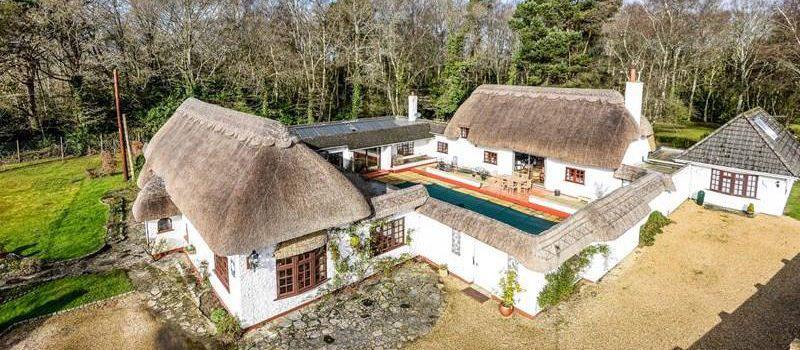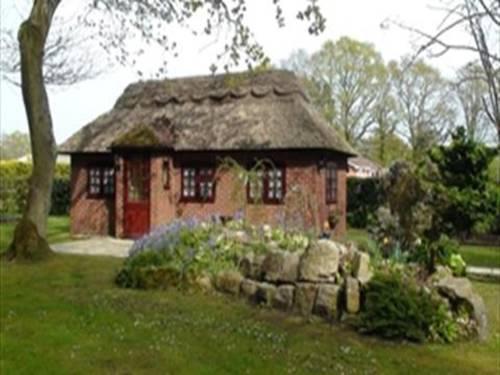The first image is the image on the left, the second image is the image on the right. Assess this claim about the two images: "Patio furniture is in front of a house.". Correct or not? Answer yes or no. No. The first image is the image on the left, the second image is the image on the right. Examine the images to the left and right. Is the description "One of the houses has a swimming pool." accurate? Answer yes or no. Yes. 